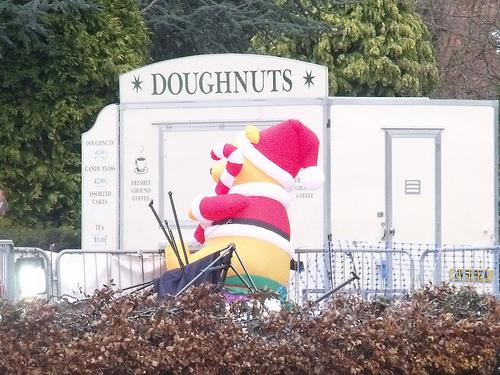Question: where was the picture taken?
Choices:
A. Outside.
B. Inside.
C. On the top.
D. On the bottom.
Answer with the letter. Answer: A Question: what does the word say?
Choices:
A. Sandwich.
B. Steak.
C. Tacos.
D. Doughnuts.
Answer with the letter. Answer: D Question: what is in front of the doughnut truck?
Choices:
A. A Christmas tree.
B. A sled.
C. A christmas blow up ornament.
D. Fake Santa.
Answer with the letter. Answer: C Question: what kind of ornament is it?
Choices:
A. A horse.
B. A dog.
C. A bear.
D. A cat.
Answer with the letter. Answer: C Question: what is the bear holding?
Choices:
A. A fish.
B. An ornament.
C. A Christmas tree.
D. A candycane.
Answer with the letter. Answer: D 